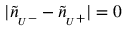Convert formula to latex. <formula><loc_0><loc_0><loc_500><loc_500>| \tilde { n } _ { U } - } - \tilde { n } _ { U } + } | = 0</formula> 